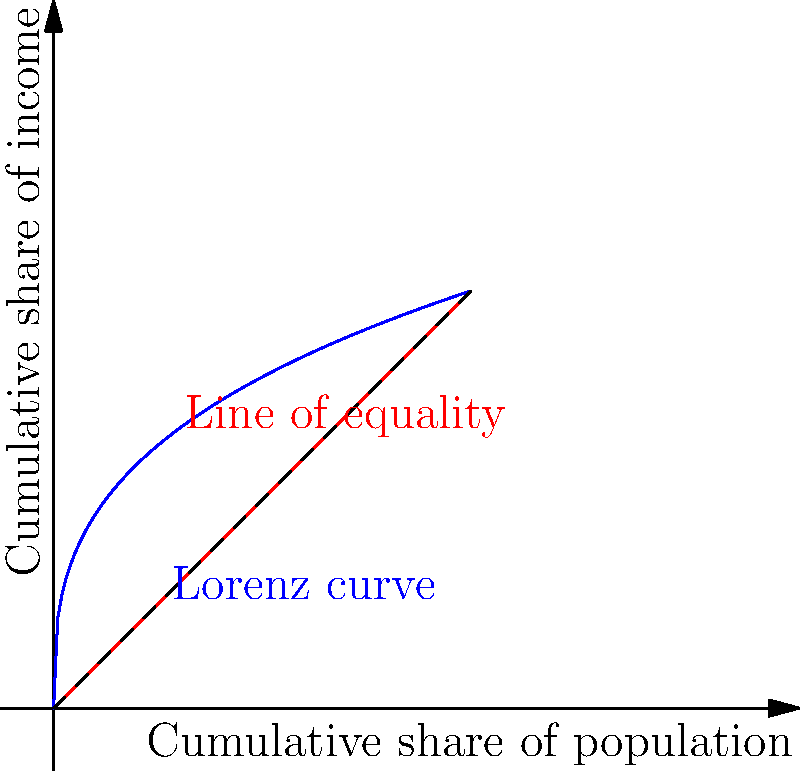As a policy analyst, you're tasked with analyzing income inequality using the Lorenz curve shown above. The area between the line of equality and the Lorenz curve is 0.3. Calculate the Gini coefficient for this income distribution. How would you interpret this result in terms of income inequality? To solve this problem, we'll follow these steps:

1. Understand the Gini coefficient:
   The Gini coefficient is a measure of income inequality ranging from 0 (perfect equality) to 1 (perfect inequality).

2. Recall the formula for the Gini coefficient:
   $$ \text{Gini coefficient} = \frac{\text{Area between Lorenz curve and line of equality}}{\text{Total area under line of equality}} $$

3. Calculate the total area under the line of equality:
   The line of equality forms a triangle with an area of $\frac{1}{2} \times 1 \times 1 = 0.5$

4. Use the given information:
   The area between the line of equality and the Lorenz curve is 0.3

5. Apply the formula:
   $$ \text{Gini coefficient} = \frac{0.3}{0.5} = 0.6 $$

6. Interpret the result:
   A Gini coefficient of 0.6 indicates a relatively high level of income inequality. It suggests that income is distributed unevenly across the population, with a significant concentration of wealth among a smaller portion of the population.

As a policy analyst, you might recommend further investigation into the causes of this inequality and potential policy interventions to address it, such as progressive taxation or social programs aimed at reducing the income gap.
Answer: Gini coefficient = 0.6, indicating high income inequality 